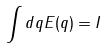<formula> <loc_0><loc_0><loc_500><loc_500>\int d q E ( q ) = I</formula> 